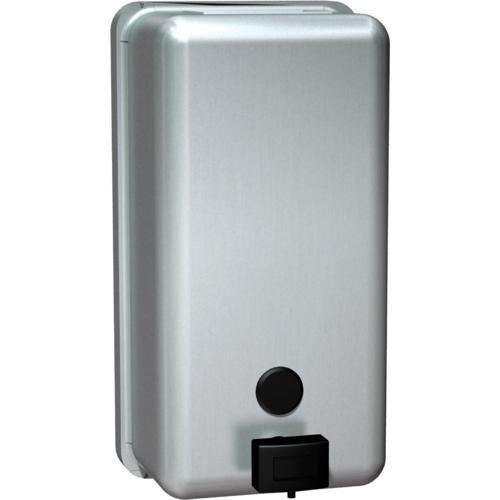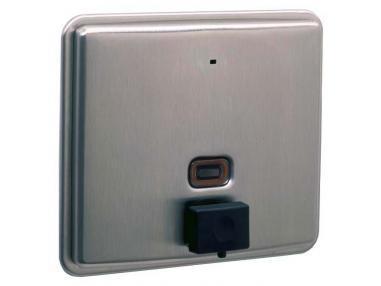The first image is the image on the left, the second image is the image on the right. Assess this claim about the two images: "The left and right image contains the same number of metal wall soap dispensers.". Correct or not? Answer yes or no. Yes. The first image is the image on the left, the second image is the image on the right. Considering the images on both sides, is "The left image features a narrower rectangular dispenser with a circle above a dark rectangular button, and the right image features a more square dispenser with a rectangle above the rectangular button on the bottom." valid? Answer yes or no. Yes. 